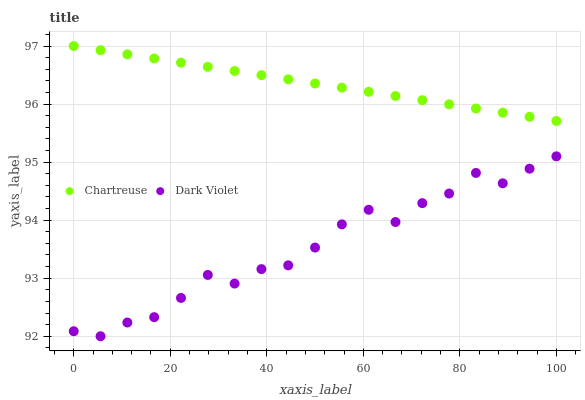Does Dark Violet have the minimum area under the curve?
Answer yes or no. Yes. Does Chartreuse have the maximum area under the curve?
Answer yes or no. Yes. Does Dark Violet have the maximum area under the curve?
Answer yes or no. No. Is Chartreuse the smoothest?
Answer yes or no. Yes. Is Dark Violet the roughest?
Answer yes or no. Yes. Is Dark Violet the smoothest?
Answer yes or no. No. Does Dark Violet have the lowest value?
Answer yes or no. Yes. Does Chartreuse have the highest value?
Answer yes or no. Yes. Does Dark Violet have the highest value?
Answer yes or no. No. Is Dark Violet less than Chartreuse?
Answer yes or no. Yes. Is Chartreuse greater than Dark Violet?
Answer yes or no. Yes. Does Dark Violet intersect Chartreuse?
Answer yes or no. No. 